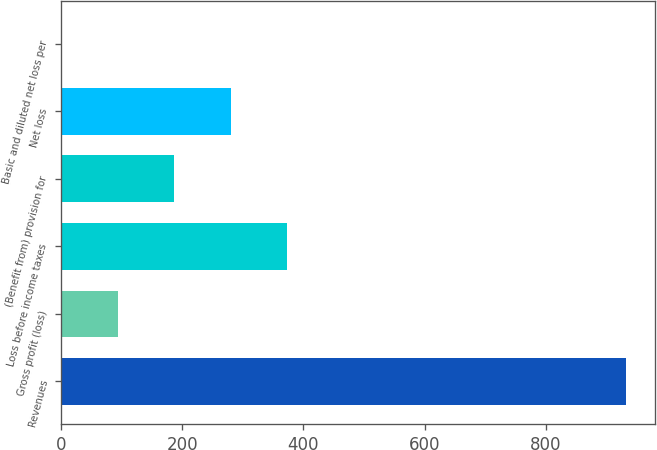Convert chart. <chart><loc_0><loc_0><loc_500><loc_500><bar_chart><fcel>Revenues<fcel>Gross profit (loss)<fcel>Loss before income taxes<fcel>(Benefit from) provision for<fcel>Net loss<fcel>Basic and diluted net loss per<nl><fcel>932.9<fcel>93.7<fcel>373.44<fcel>186.94<fcel>280.19<fcel>0.45<nl></chart> 